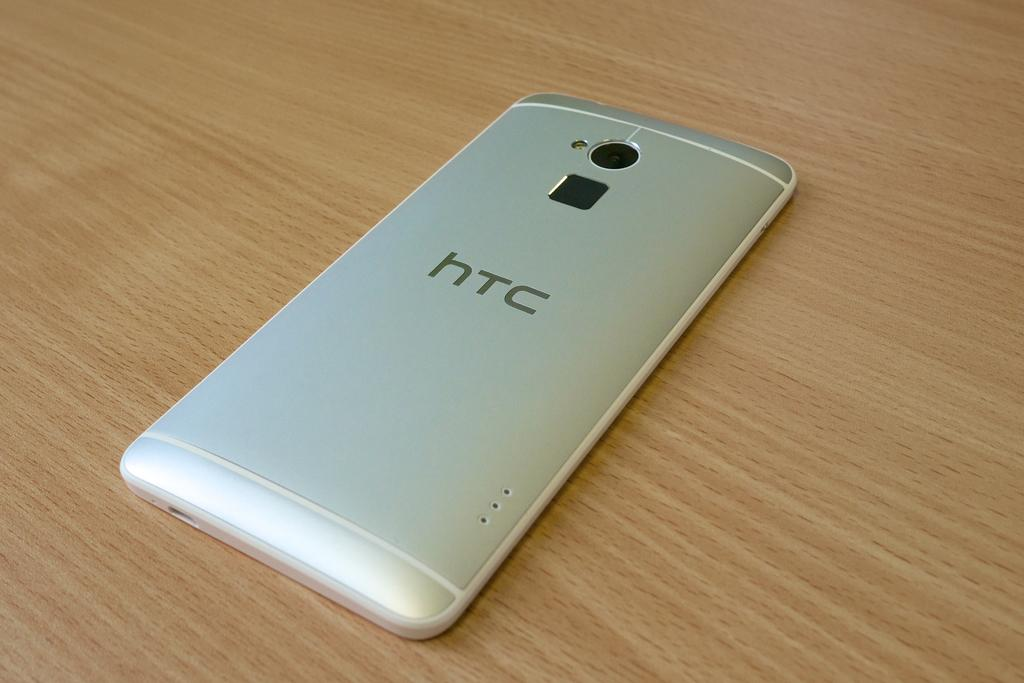Provide a one-sentence caption for the provided image. The HTC phone is laying face down on the table. 